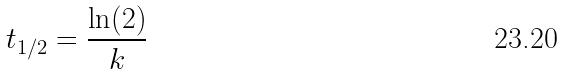<formula> <loc_0><loc_0><loc_500><loc_500>t _ { 1 / 2 } = \frac { \ln ( 2 ) } { k }</formula> 